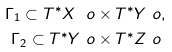<formula> <loc_0><loc_0><loc_500><loc_500>\Gamma _ { 1 } \subset T ^ { * } X \ o & \times T ^ { * } Y \ o , \\ \Gamma _ { 2 } \subset T ^ { * } Y \ o & \times T ^ { * } Z \ o</formula> 